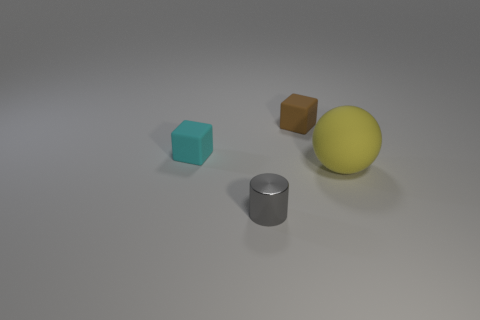How many cylinders are tiny blue shiny things or big rubber objects?
Keep it short and to the point. 0. What color is the ball?
Your answer should be compact. Yellow. Is the number of cyan things greater than the number of tiny matte things?
Provide a short and direct response. No. How many objects are rubber blocks to the right of the tiny cyan matte object or tiny brown rubber cubes?
Your response must be concise. 1. Are the small cylinder and the yellow ball made of the same material?
Your answer should be compact. No. What is the size of the cyan rubber thing that is the same shape as the brown rubber thing?
Keep it short and to the point. Small. Is the shape of the small cyan object that is behind the tiny metallic thing the same as the tiny thing that is in front of the sphere?
Offer a very short reply. No. Does the shiny cylinder have the same size as the rubber cube left of the shiny cylinder?
Ensure brevity in your answer.  Yes. What number of other things are there of the same material as the big ball
Your response must be concise. 2. Is there anything else that has the same shape as the tiny cyan rubber thing?
Your answer should be compact. Yes. 